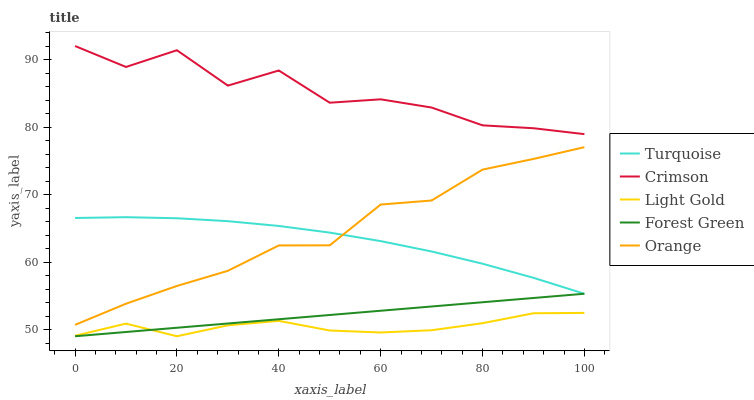Does Light Gold have the minimum area under the curve?
Answer yes or no. Yes. Does Crimson have the maximum area under the curve?
Answer yes or no. Yes. Does Orange have the minimum area under the curve?
Answer yes or no. No. Does Orange have the maximum area under the curve?
Answer yes or no. No. Is Forest Green the smoothest?
Answer yes or no. Yes. Is Crimson the roughest?
Answer yes or no. Yes. Is Orange the smoothest?
Answer yes or no. No. Is Orange the roughest?
Answer yes or no. No. Does Light Gold have the lowest value?
Answer yes or no. Yes. Does Orange have the lowest value?
Answer yes or no. No. Does Crimson have the highest value?
Answer yes or no. Yes. Does Orange have the highest value?
Answer yes or no. No. Is Forest Green less than Crimson?
Answer yes or no. Yes. Is Crimson greater than Orange?
Answer yes or no. Yes. Does Forest Green intersect Turquoise?
Answer yes or no. Yes. Is Forest Green less than Turquoise?
Answer yes or no. No. Is Forest Green greater than Turquoise?
Answer yes or no. No. Does Forest Green intersect Crimson?
Answer yes or no. No. 